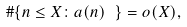Convert formula to latex. <formula><loc_0><loc_0><loc_500><loc_500>\# \{ n \leq X \colon a ( n ) \ \} = o ( X ) ,</formula> 